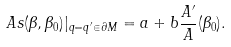Convert formula to latex. <formula><loc_0><loc_0><loc_500><loc_500>A s ( \beta , \beta _ { 0 } ) | _ { q = q ^ { \prime } \in \partial M } = a + b \frac { A ^ { \prime } } { A } ( \beta _ { 0 } ) .</formula> 